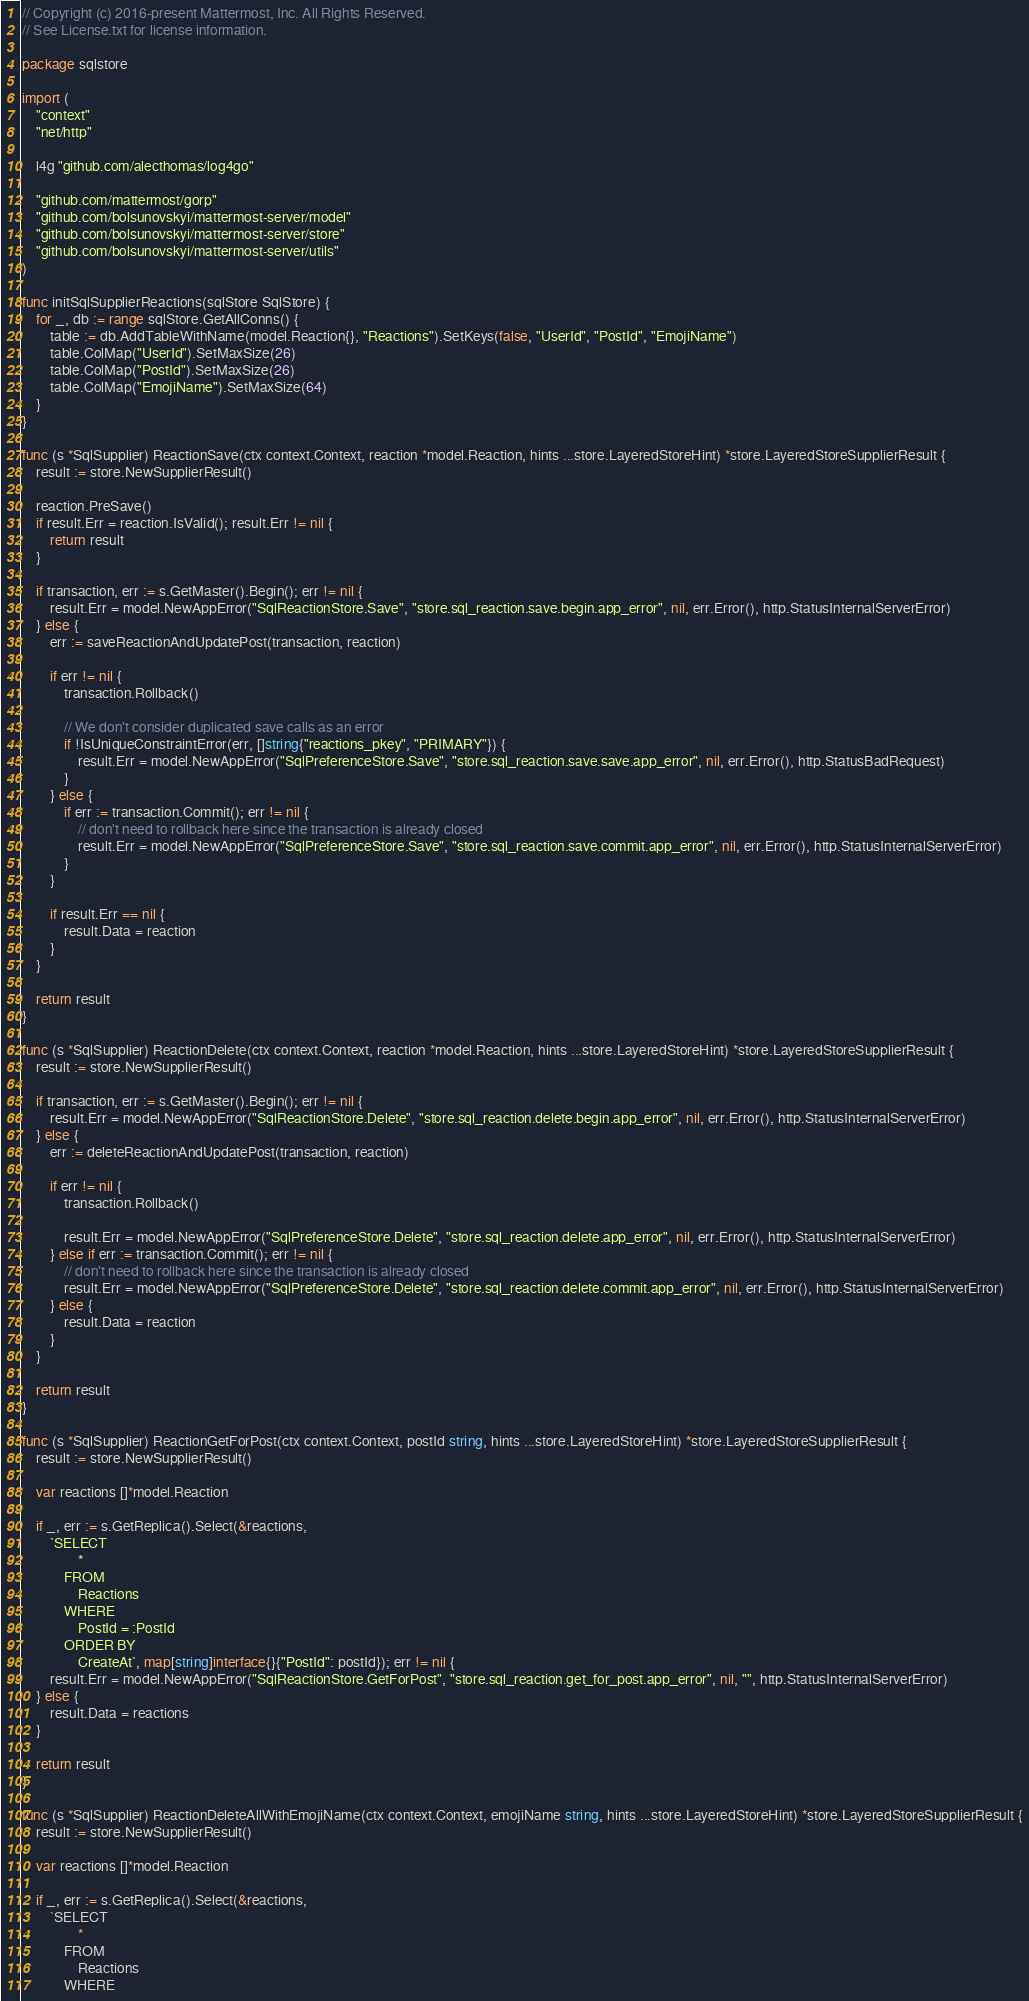Convert code to text. <code><loc_0><loc_0><loc_500><loc_500><_Go_>// Copyright (c) 2016-present Mattermost, Inc. All Rights Reserved.
// See License.txt for license information.

package sqlstore

import (
	"context"
	"net/http"

	l4g "github.com/alecthomas/log4go"

	"github.com/mattermost/gorp"
	"github.com/bolsunovskyi/mattermost-server/model"
	"github.com/bolsunovskyi/mattermost-server/store"
	"github.com/bolsunovskyi/mattermost-server/utils"
)

func initSqlSupplierReactions(sqlStore SqlStore) {
	for _, db := range sqlStore.GetAllConns() {
		table := db.AddTableWithName(model.Reaction{}, "Reactions").SetKeys(false, "UserId", "PostId", "EmojiName")
		table.ColMap("UserId").SetMaxSize(26)
		table.ColMap("PostId").SetMaxSize(26)
		table.ColMap("EmojiName").SetMaxSize(64)
	}
}

func (s *SqlSupplier) ReactionSave(ctx context.Context, reaction *model.Reaction, hints ...store.LayeredStoreHint) *store.LayeredStoreSupplierResult {
	result := store.NewSupplierResult()

	reaction.PreSave()
	if result.Err = reaction.IsValid(); result.Err != nil {
		return result
	}

	if transaction, err := s.GetMaster().Begin(); err != nil {
		result.Err = model.NewAppError("SqlReactionStore.Save", "store.sql_reaction.save.begin.app_error", nil, err.Error(), http.StatusInternalServerError)
	} else {
		err := saveReactionAndUpdatePost(transaction, reaction)

		if err != nil {
			transaction.Rollback()

			// We don't consider duplicated save calls as an error
			if !IsUniqueConstraintError(err, []string{"reactions_pkey", "PRIMARY"}) {
				result.Err = model.NewAppError("SqlPreferenceStore.Save", "store.sql_reaction.save.save.app_error", nil, err.Error(), http.StatusBadRequest)
			}
		} else {
			if err := transaction.Commit(); err != nil {
				// don't need to rollback here since the transaction is already closed
				result.Err = model.NewAppError("SqlPreferenceStore.Save", "store.sql_reaction.save.commit.app_error", nil, err.Error(), http.StatusInternalServerError)
			}
		}

		if result.Err == nil {
			result.Data = reaction
		}
	}

	return result
}

func (s *SqlSupplier) ReactionDelete(ctx context.Context, reaction *model.Reaction, hints ...store.LayeredStoreHint) *store.LayeredStoreSupplierResult {
	result := store.NewSupplierResult()

	if transaction, err := s.GetMaster().Begin(); err != nil {
		result.Err = model.NewAppError("SqlReactionStore.Delete", "store.sql_reaction.delete.begin.app_error", nil, err.Error(), http.StatusInternalServerError)
	} else {
		err := deleteReactionAndUpdatePost(transaction, reaction)

		if err != nil {
			transaction.Rollback()

			result.Err = model.NewAppError("SqlPreferenceStore.Delete", "store.sql_reaction.delete.app_error", nil, err.Error(), http.StatusInternalServerError)
		} else if err := transaction.Commit(); err != nil {
			// don't need to rollback here since the transaction is already closed
			result.Err = model.NewAppError("SqlPreferenceStore.Delete", "store.sql_reaction.delete.commit.app_error", nil, err.Error(), http.StatusInternalServerError)
		} else {
			result.Data = reaction
		}
	}

	return result
}

func (s *SqlSupplier) ReactionGetForPost(ctx context.Context, postId string, hints ...store.LayeredStoreHint) *store.LayeredStoreSupplierResult {
	result := store.NewSupplierResult()

	var reactions []*model.Reaction

	if _, err := s.GetReplica().Select(&reactions,
		`SELECT
				*
			FROM
				Reactions
			WHERE
				PostId = :PostId
			ORDER BY
				CreateAt`, map[string]interface{}{"PostId": postId}); err != nil {
		result.Err = model.NewAppError("SqlReactionStore.GetForPost", "store.sql_reaction.get_for_post.app_error", nil, "", http.StatusInternalServerError)
	} else {
		result.Data = reactions
	}

	return result
}

func (s *SqlSupplier) ReactionDeleteAllWithEmojiName(ctx context.Context, emojiName string, hints ...store.LayeredStoreHint) *store.LayeredStoreSupplierResult {
	result := store.NewSupplierResult()

	var reactions []*model.Reaction

	if _, err := s.GetReplica().Select(&reactions,
		`SELECT
				*
			FROM
				Reactions
			WHERE</code> 